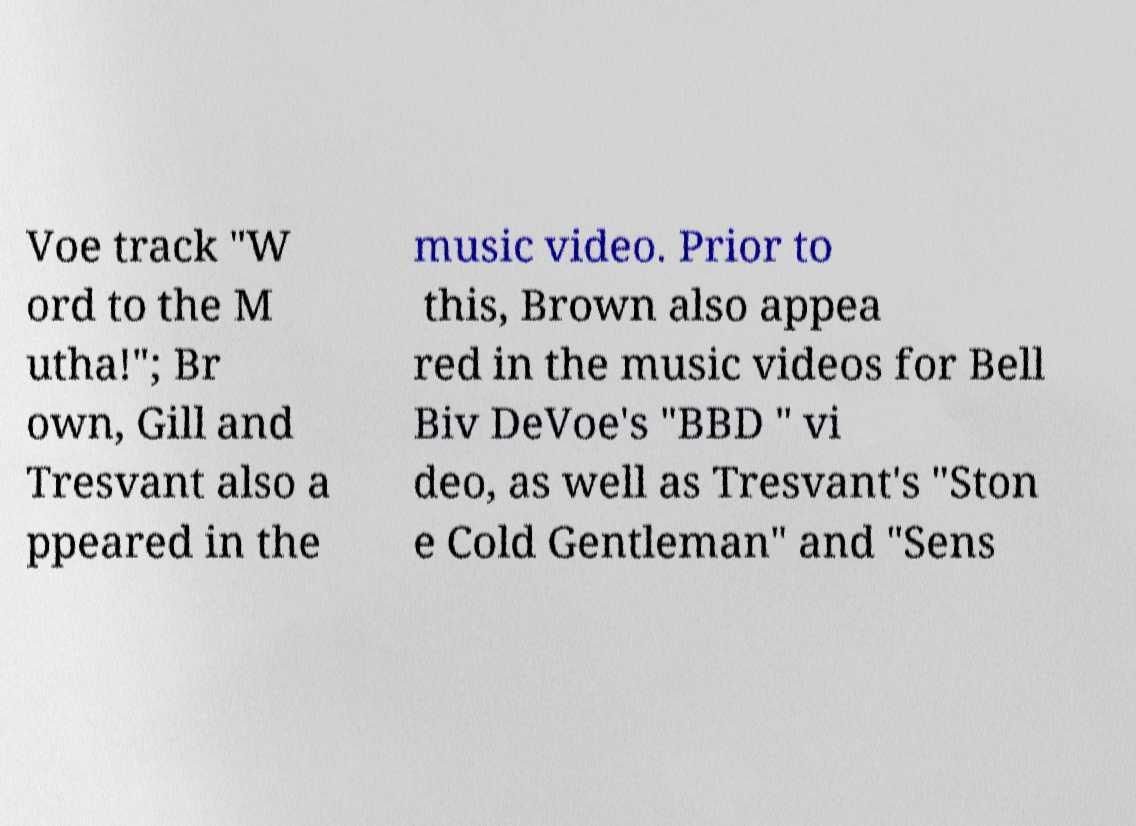Could you extract and type out the text from this image? Voe track "W ord to the M utha!"; Br own, Gill and Tresvant also a ppeared in the music video. Prior to this, Brown also appea red in the music videos for Bell Biv DeVoe's "BBD " vi deo, as well as Tresvant's "Ston e Cold Gentleman" and "Sens 